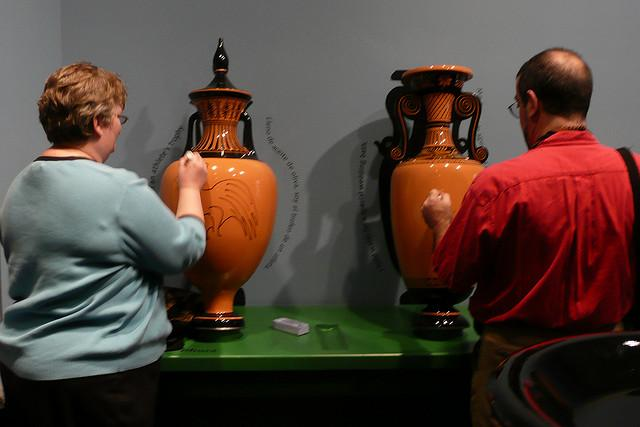What is the woman drawing?

Choices:
A) pigeon
B) camel
C) peacock
D) rooster rooster 